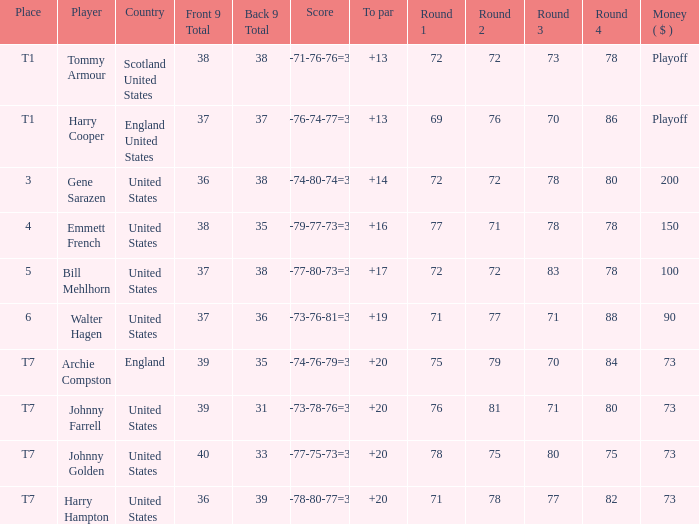Could you help me parse every detail presented in this table? {'header': ['Place', 'Player', 'Country', 'Front 9 Total', 'Back 9 Total', 'Score', 'To par', 'Round 1', 'Round 2', 'Round 3', 'Round 4', 'Money ( $ )'], 'rows': [['T1', 'Tommy Armour', 'Scotland United States', '38', '38', '78-71-76-76=301', '+13', '72', '72', '73', '78', 'Playoff'], ['T1', 'Harry Cooper', 'England United States', '37', '37', '74-76-74-77=301', '+13', '69', '76', '70', '86', 'Playoff'], ['3', 'Gene Sarazen', 'United States', '36', '38', '74-74-80-74=302', '+14', '72', '72', '78', '80', '200'], ['4', 'Emmett French', 'United States', '38', '35', '75-79-77-73=304', '+16', '77', '71', '78', '78', '150'], ['5', 'Bill Mehlhorn', 'United States', '37', '38', '75-77-80-73=305', '+17', '72', '72', '83', '78', '100'], ['6', 'Walter Hagen', 'United States', '37', '36', '77-73-76-81=307', '+19', '71', '77', '71', '88', '90'], ['T7', 'Archie Compston', 'England', '39', '35', '79-74-76-79=308', '+20', '75', '79', '70', '84', '73'], ['T7', 'Johnny Farrell', 'United States', '39', '31', '81-73-78-76=308', '+20', '76', '81', '71', '80', '73'], ['T7', 'Johnny Golden', 'United States', '40', '33', '83-77-75-73=308', '+20', '78', '75', '80', '75', '73'], ['T7', 'Harry Hampton', 'United States', '36', '39', '73-78-80-77=308', '+20', '71', '78', '77', '82', '73']]} What is the ranking when Archie Compston is the player and the money is $73? T7. 